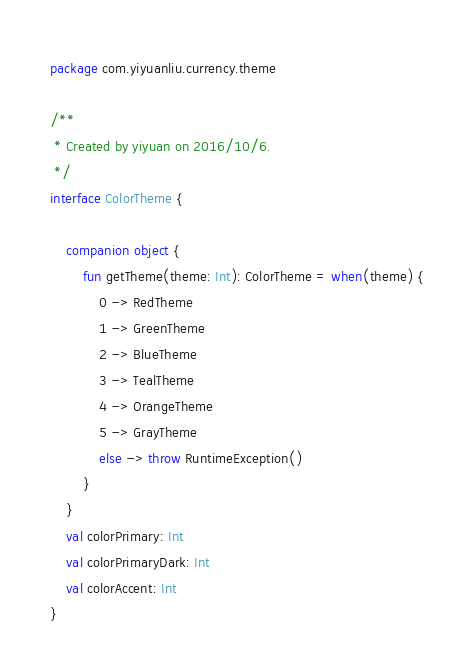Convert code to text. <code><loc_0><loc_0><loc_500><loc_500><_Kotlin_>package com.yiyuanliu.currency.theme

/**
 * Created by yiyuan on 2016/10/6.
 */
interface ColorTheme {

    companion object {
        fun getTheme(theme: Int): ColorTheme = when(theme) {
            0 -> RedTheme
            1 -> GreenTheme
            2 -> BlueTheme
            3 -> TealTheme
            4 -> OrangeTheme
            5 -> GrayTheme
            else -> throw RuntimeException()
        }
    }
    val colorPrimary: Int
    val colorPrimaryDark: Int
    val colorAccent: Int
}</code> 